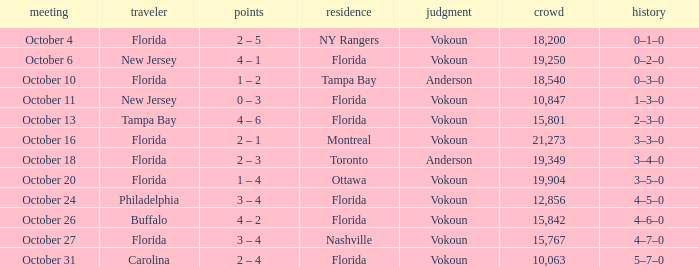Which team won when the visitor was Carolina? Vokoun. 